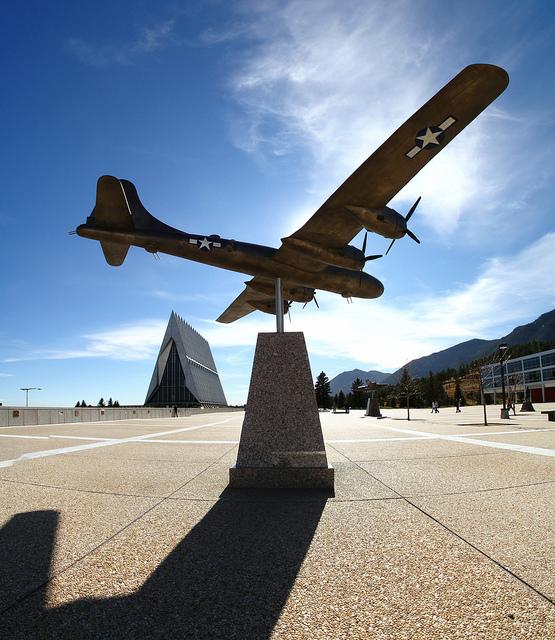Why is this plane on display?
Answer briefly. War plane. Is this a real plane?
Short answer required. No. Is the sky clear?
Short answer required. Yes. 